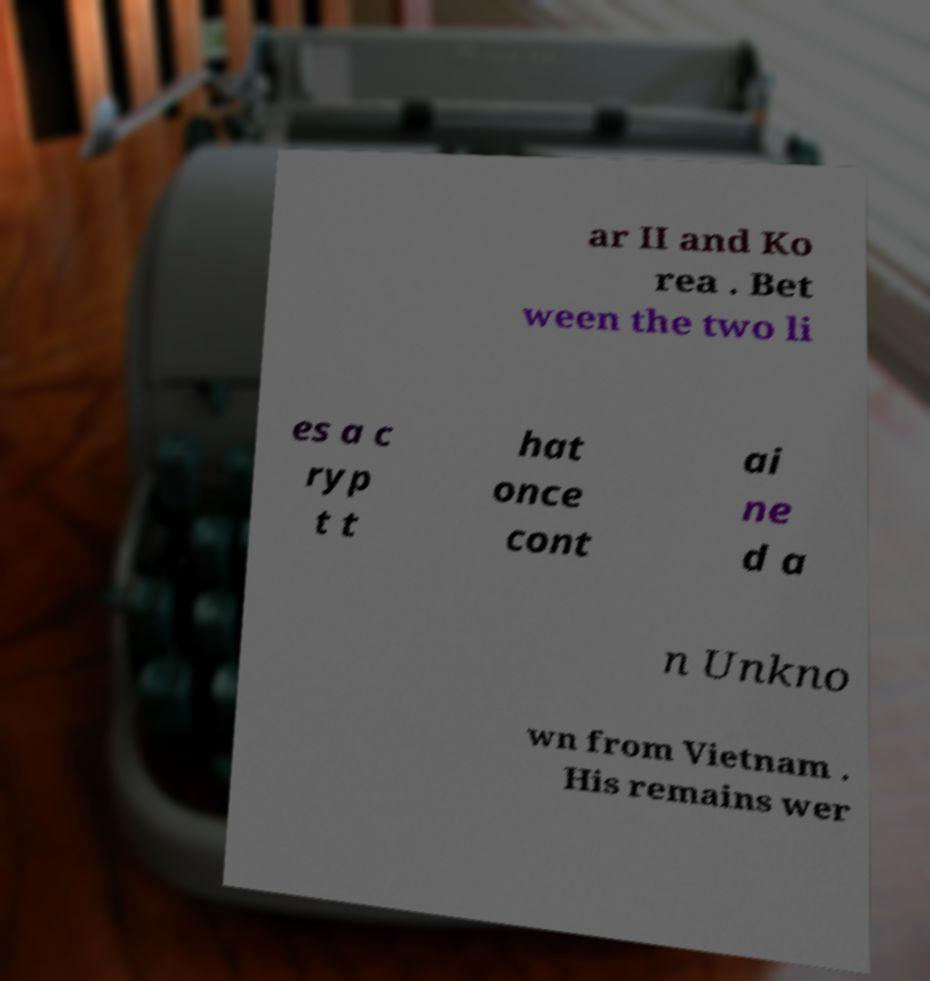Can you accurately transcribe the text from the provided image for me? ar II and Ko rea . Bet ween the two li es a c ryp t t hat once cont ai ne d a n Unkno wn from Vietnam . His remains wer 